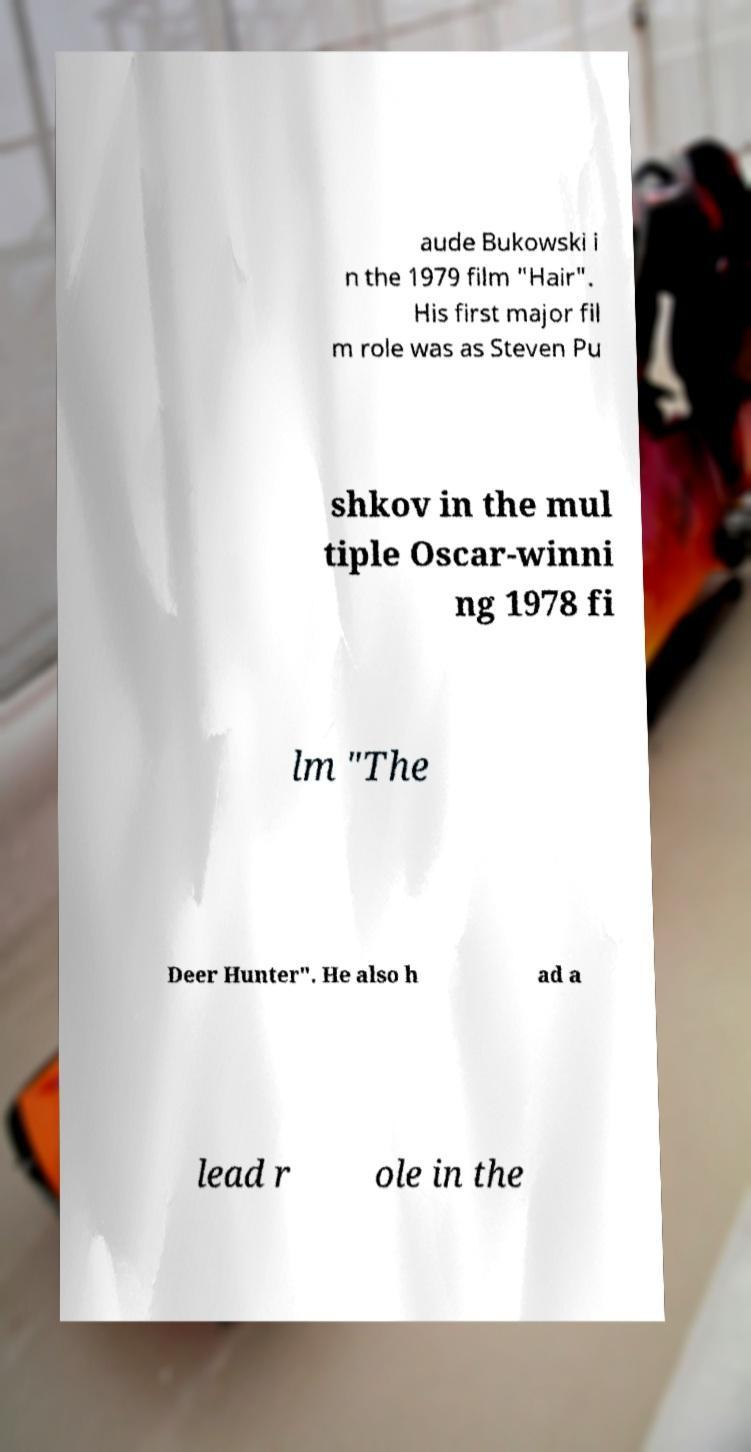There's text embedded in this image that I need extracted. Can you transcribe it verbatim? aude Bukowski i n the 1979 film "Hair". His first major fil m role was as Steven Pu shkov in the mul tiple Oscar-winni ng 1978 fi lm "The Deer Hunter". He also h ad a lead r ole in the 